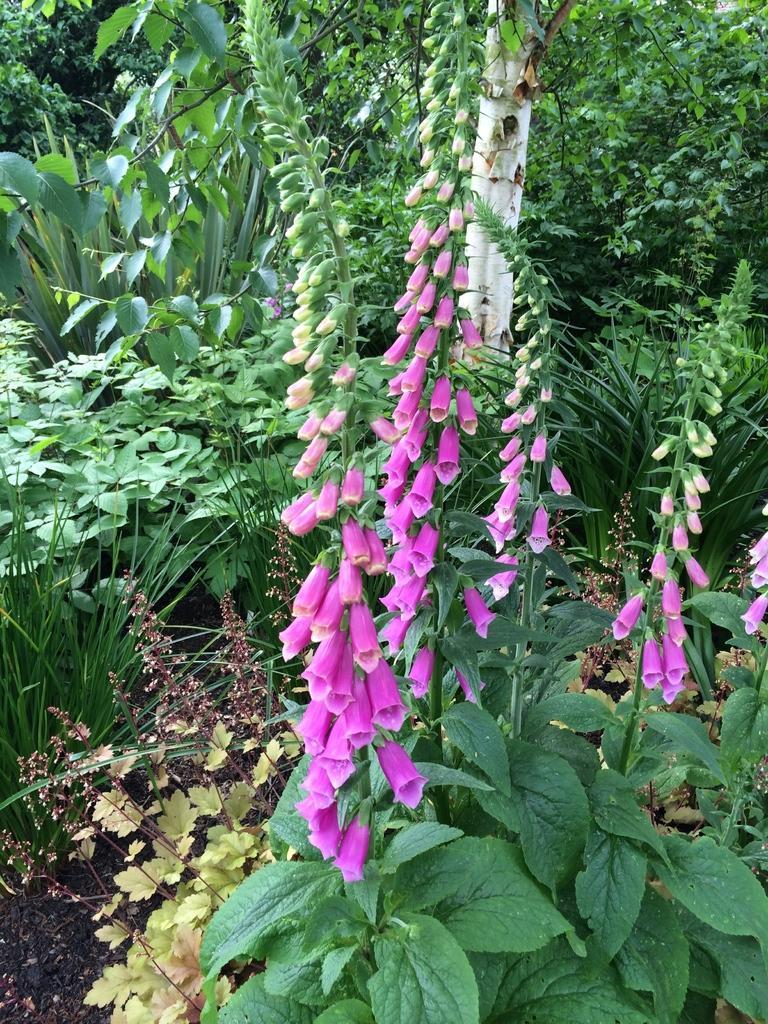How would you summarize this image in a sentence or two? In the image I can see trees with flowers and leaves. 